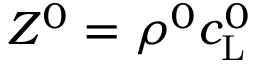Convert formula to latex. <formula><loc_0><loc_0><loc_500><loc_500>Z ^ { 0 } = \rho ^ { 0 } c _ { L } ^ { 0 }</formula> 